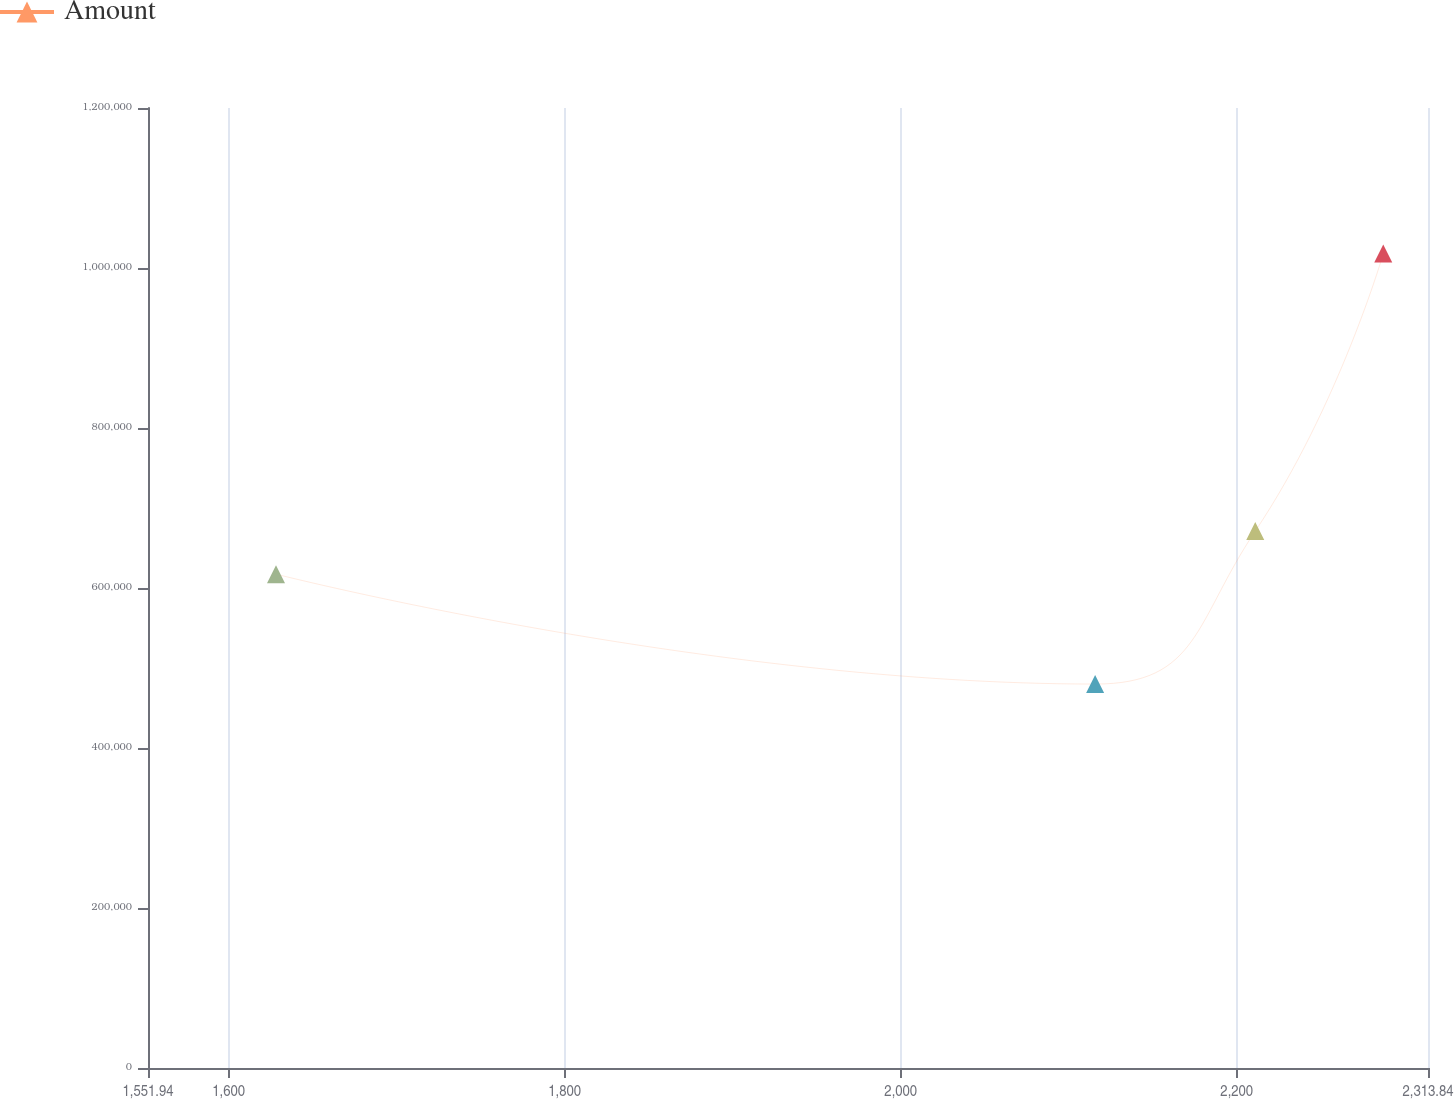Convert chart. <chart><loc_0><loc_0><loc_500><loc_500><line_chart><ecel><fcel>Amount<nl><fcel>1628.13<fcel>617319<nl><fcel>2115.71<fcel>479924<nl><fcel>2211.03<fcel>671127<nl><fcel>2287.22<fcel>1.018e+06<nl><fcel>2390.03<fcel>724935<nl></chart> 